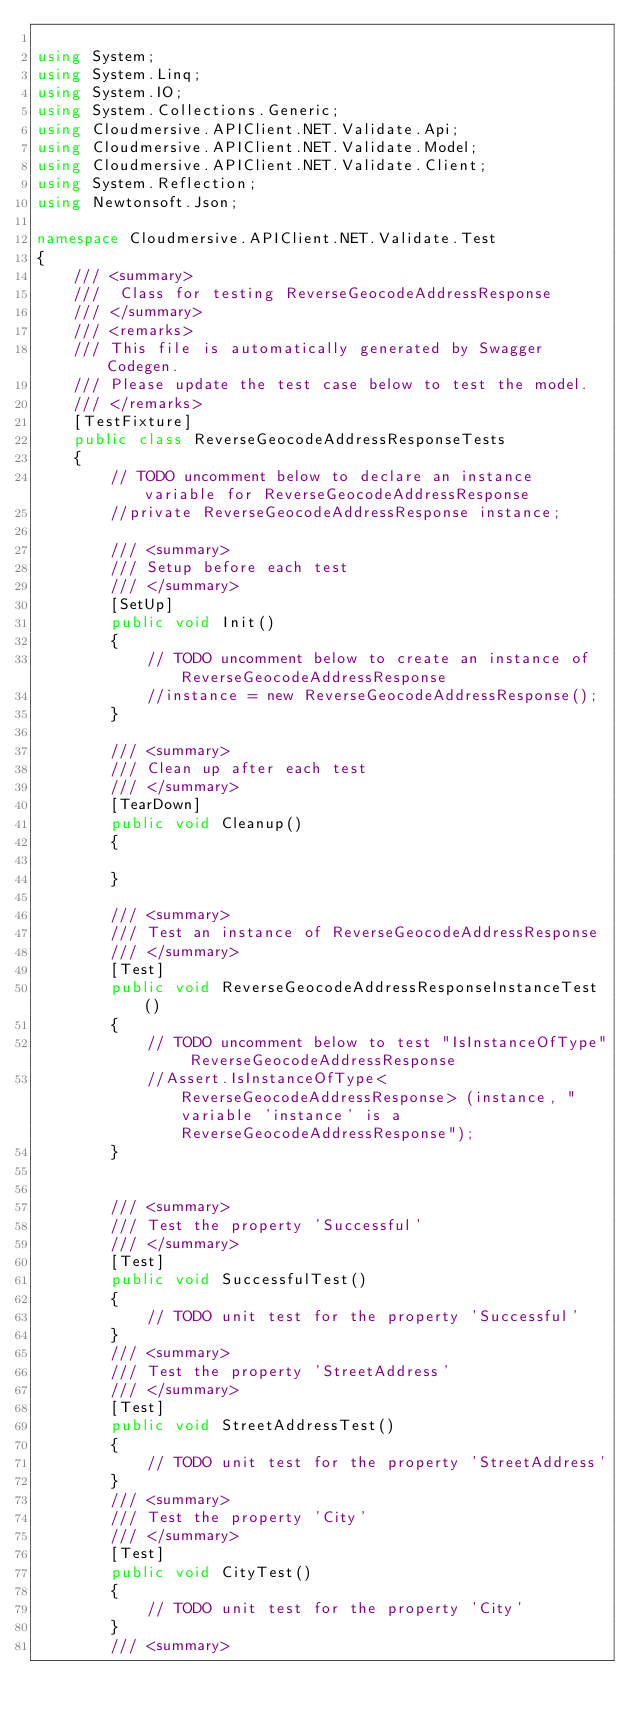Convert code to text. <code><loc_0><loc_0><loc_500><loc_500><_C#_>
using System;
using System.Linq;
using System.IO;
using System.Collections.Generic;
using Cloudmersive.APIClient.NET.Validate.Api;
using Cloudmersive.APIClient.NET.Validate.Model;
using Cloudmersive.APIClient.NET.Validate.Client;
using System.Reflection;
using Newtonsoft.Json;

namespace Cloudmersive.APIClient.NET.Validate.Test
{
    /// <summary>
    ///  Class for testing ReverseGeocodeAddressResponse
    /// </summary>
    /// <remarks>
    /// This file is automatically generated by Swagger Codegen.
    /// Please update the test case below to test the model.
    /// </remarks>
    [TestFixture]
    public class ReverseGeocodeAddressResponseTests
    {
        // TODO uncomment below to declare an instance variable for ReverseGeocodeAddressResponse
        //private ReverseGeocodeAddressResponse instance;

        /// <summary>
        /// Setup before each test
        /// </summary>
        [SetUp]
        public void Init()
        {
            // TODO uncomment below to create an instance of ReverseGeocodeAddressResponse
            //instance = new ReverseGeocodeAddressResponse();
        }

        /// <summary>
        /// Clean up after each test
        /// </summary>
        [TearDown]
        public void Cleanup()
        {

        }

        /// <summary>
        /// Test an instance of ReverseGeocodeAddressResponse
        /// </summary>
        [Test]
        public void ReverseGeocodeAddressResponseInstanceTest()
        {
            // TODO uncomment below to test "IsInstanceOfType" ReverseGeocodeAddressResponse
            //Assert.IsInstanceOfType<ReverseGeocodeAddressResponse> (instance, "variable 'instance' is a ReverseGeocodeAddressResponse");
        }


        /// <summary>
        /// Test the property 'Successful'
        /// </summary>
        [Test]
        public void SuccessfulTest()
        {
            // TODO unit test for the property 'Successful'
        }
        /// <summary>
        /// Test the property 'StreetAddress'
        /// </summary>
        [Test]
        public void StreetAddressTest()
        {
            // TODO unit test for the property 'StreetAddress'
        }
        /// <summary>
        /// Test the property 'City'
        /// </summary>
        [Test]
        public void CityTest()
        {
            // TODO unit test for the property 'City'
        }
        /// <summary></code> 